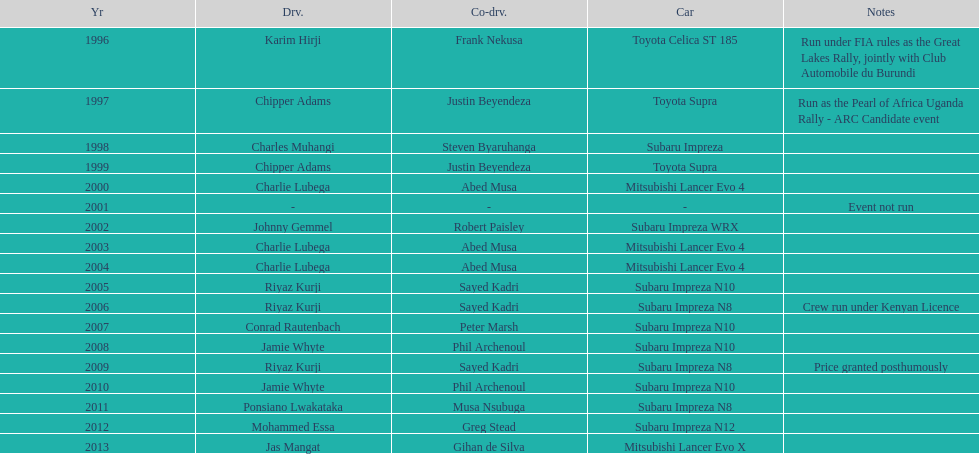Chipper adams and justin beyendeza have how mnay wins? 2. 